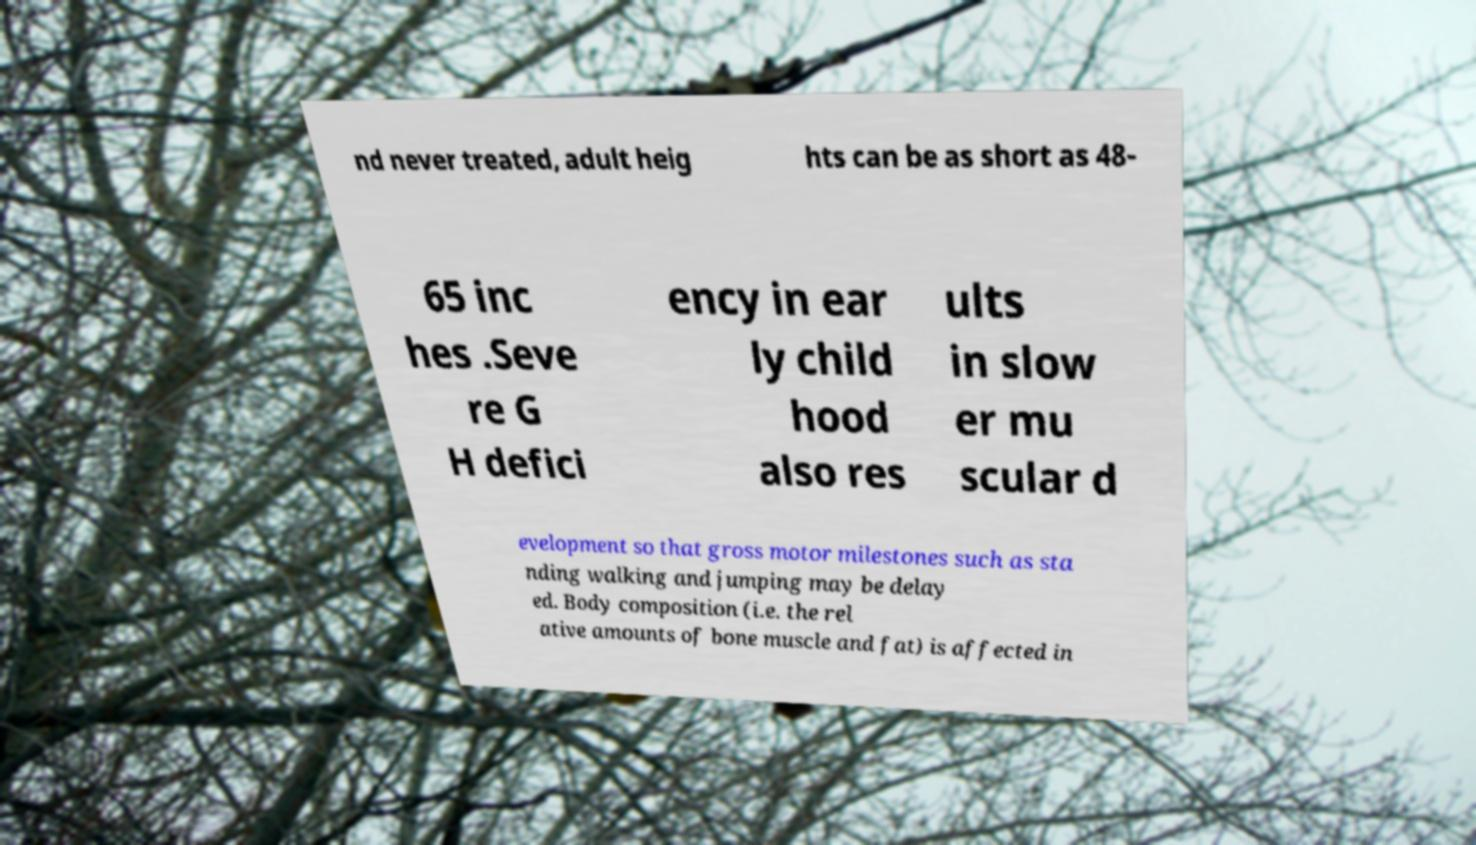Can you accurately transcribe the text from the provided image for me? nd never treated, adult heig hts can be as short as 48- 65 inc hes .Seve re G H defici ency in ear ly child hood also res ults in slow er mu scular d evelopment so that gross motor milestones such as sta nding walking and jumping may be delay ed. Body composition (i.e. the rel ative amounts of bone muscle and fat) is affected in 